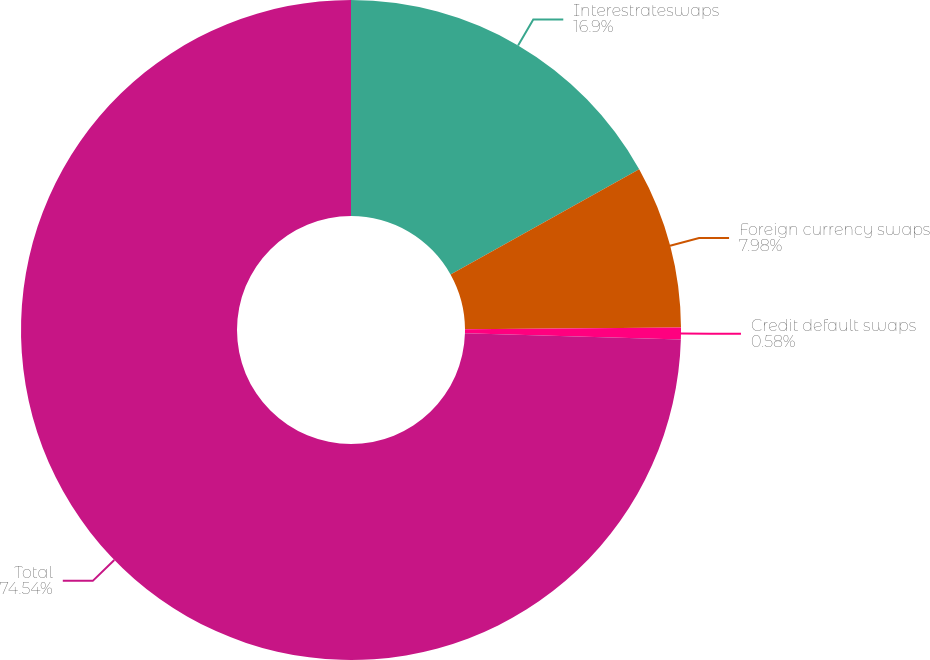Convert chart to OTSL. <chart><loc_0><loc_0><loc_500><loc_500><pie_chart><fcel>Interestrateswaps<fcel>Foreign currency swaps<fcel>Credit default swaps<fcel>Total<nl><fcel>16.9%<fcel>7.98%<fcel>0.58%<fcel>74.54%<nl></chart> 